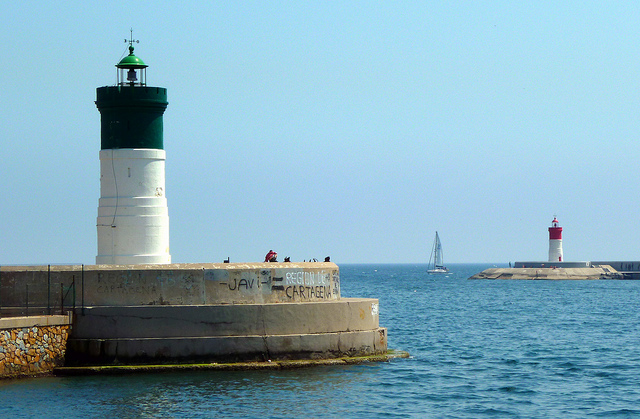How many lighthouses do you see? 2 